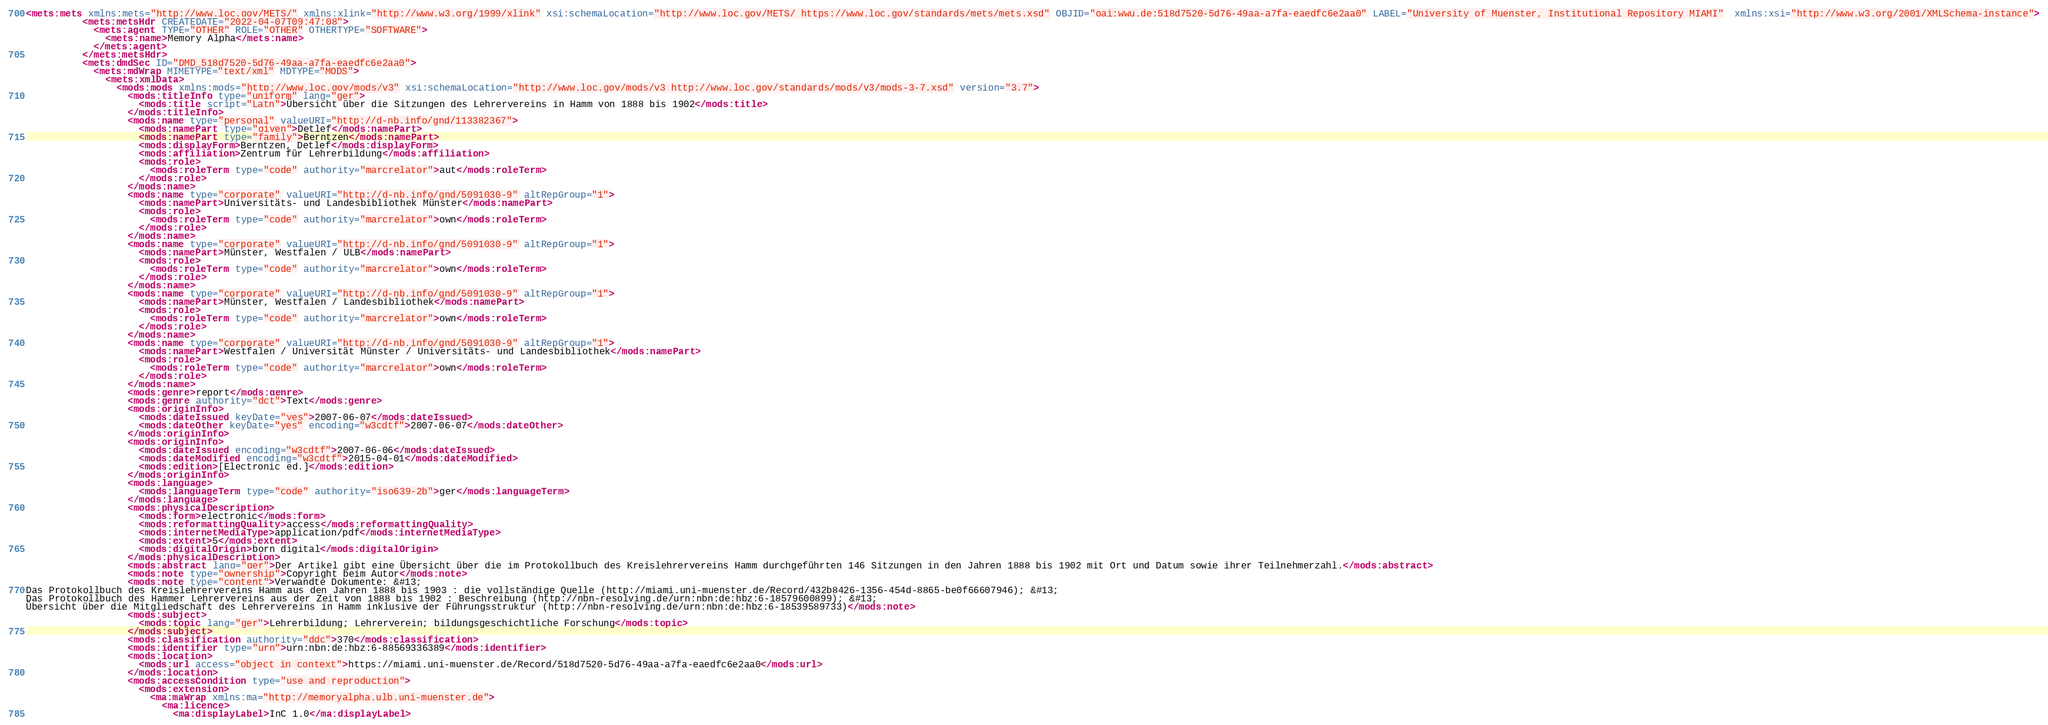<code> <loc_0><loc_0><loc_500><loc_500><_XML_><mets:mets xmlns:mets="http://www.loc.gov/METS/" xmlns:xlink="http://www.w3.org/1999/xlink" xsi:schemaLocation="http://www.loc.gov/METS/ https://www.loc.gov/standards/mets/mets.xsd" OBJID="oai:wwu.de:518d7520-5d76-49aa-a7fa-eaedfc6e2aa0" LABEL="University of Muenster, Institutional Repository MIAMI"  xmlns:xsi="http://www.w3.org/2001/XMLSchema-instance">
          <mets:metsHdr CREATEDATE="2022-04-07T09:47:08">
            <mets:agent TYPE="OTHER" ROLE="OTHER" OTHERTYPE="SOFTWARE">
              <mets:name>Memory Alpha</mets:name>
            </mets:agent>
          </mets:metsHdr>
          <mets:dmdSec ID="DMD_518d7520-5d76-49aa-a7fa-eaedfc6e2aa0">
            <mets:mdWrap MIMETYPE="text/xml" MDTYPE="MODS">
              <mets:xmlData>
                <mods:mods xmlns:mods="http://www.loc.gov/mods/v3" xsi:schemaLocation="http://www.loc.gov/mods/v3 http://www.loc.gov/standards/mods/v3/mods-3-7.xsd" version="3.7">
                  <mods:titleInfo type="uniform" lang="ger">
                    <mods:title script="Latn">Übersicht über die Sitzungen des Lehrervereins in Hamm von 1888 bis 1902</mods:title>
                  </mods:titleInfo>
                  <mods:name type="personal" valueURI="http://d-nb.info/gnd/113382367">
                    <mods:namePart type="given">Detlef</mods:namePart>
                    <mods:namePart type="family">Berntzen</mods:namePart>
                    <mods:displayForm>Berntzen, Detlef</mods:displayForm>
                    <mods:affiliation>Zentrum für Lehrerbildung</mods:affiliation>
                    <mods:role>
                      <mods:roleTerm type="code" authority="marcrelator">aut</mods:roleTerm>
                    </mods:role>
                  </mods:name>
                  <mods:name type="corporate" valueURI="http://d-nb.info/gnd/5091030-9" altRepGroup="1">
                    <mods:namePart>Universitäts- und Landesbibliothek Münster</mods:namePart>
                    <mods:role>
                      <mods:roleTerm type="code" authority="marcrelator">own</mods:roleTerm>
                    </mods:role>
                  </mods:name>
                  <mods:name type="corporate" valueURI="http://d-nb.info/gnd/5091030-9" altRepGroup="1">
                    <mods:namePart>Münster, Westfalen / ULB</mods:namePart>
                    <mods:role>
                      <mods:roleTerm type="code" authority="marcrelator">own</mods:roleTerm>
                    </mods:role>
                  </mods:name>
                  <mods:name type="corporate" valueURI="http://d-nb.info/gnd/5091030-9" altRepGroup="1">
                    <mods:namePart>Münster, Westfalen / Landesbibliothek</mods:namePart>
                    <mods:role>
                      <mods:roleTerm type="code" authority="marcrelator">own</mods:roleTerm>
                    </mods:role>
                  </mods:name>
                  <mods:name type="corporate" valueURI="http://d-nb.info/gnd/5091030-9" altRepGroup="1">
                    <mods:namePart>Westfalen / Universität Münster / Universitäts- und Landesbibliothek</mods:namePart>
                    <mods:role>
                      <mods:roleTerm type="code" authority="marcrelator">own</mods:roleTerm>
                    </mods:role>
                  </mods:name>
                  <mods:genre>report</mods:genre>
                  <mods:genre authority="dct">Text</mods:genre>
                  <mods:originInfo>
                    <mods:dateIssued keyDate="yes">2007-06-07</mods:dateIssued>
                    <mods:dateOther keyDate="yes" encoding="w3cdtf">2007-06-07</mods:dateOther>
                  </mods:originInfo>
                  <mods:originInfo>
                    <mods:dateIssued encoding="w3cdtf">2007-06-06</mods:dateIssued>
                    <mods:dateModified encoding="w3cdtf">2015-04-01</mods:dateModified>
                    <mods:edition>[Electronic ed.]</mods:edition>
                  </mods:originInfo>
                  <mods:language>
                    <mods:languageTerm type="code" authority="iso639-2b">ger</mods:languageTerm>
                  </mods:language>
                  <mods:physicalDescription>
                    <mods:form>electronic</mods:form>
                    <mods:reformattingQuality>access</mods:reformattingQuality>
                    <mods:internetMediaType>application/pdf</mods:internetMediaType>
                    <mods:extent>5</mods:extent>
                    <mods:digitalOrigin>born digital</mods:digitalOrigin>
                  </mods:physicalDescription>
                  <mods:abstract lang="ger">Der Artikel gibt eine Übersicht über die im Protokollbuch des Kreislehrervereins Hamm durchgeführten 146 Sitzungen in den Jahren 1888 bis 1902 mit Ort und Datum sowie ihrer Teilnehmerzahl.</mods:abstract>
                  <mods:note type="ownership">Copyright beim Autor</mods:note>
                  <mods:note type="content">Verwandte Dokumente: &#13;
Das Protokollbuch des Kreislehrervereins Hamm aus den Jahren 1888 bis 1903 : die vollständige Quelle (http://miami.uni-muenster.de/Record/432b8426-1356-454d-8865-be0f66607946); &#13;
Das Protokollbuch des Hammer Lehrervereins aus der Zeit von 1888 bis 1902 : Beschreibung (http://nbn-resolving.de/urn:nbn:de:hbz:6-18579600899); &#13;
Übersicht über die Mitgliedschaft des Lehrervereins in Hamm inklusive der Führungsstruktur (http://nbn-resolving.de/urn:nbn:de:hbz:6-18539589733)</mods:note>
                  <mods:subject>
                    <mods:topic lang="ger">Lehrerbildung; Lehrerverein; bildungsgeschichtliche Forschung</mods:topic>
                  </mods:subject>
                  <mods:classification authority="ddc">370</mods:classification>
                  <mods:identifier type="urn">urn:nbn:de:hbz:6-88569336389</mods:identifier>
                  <mods:location>
                    <mods:url access="object in context">https://miami.uni-muenster.de/Record/518d7520-5d76-49aa-a7fa-eaedfc6e2aa0</mods:url>
                  </mods:location>
                  <mods:accessCondition type="use and reproduction">
                    <mods:extension>
                      <ma:maWrap xmlns:ma="http://memoryalpha.ulb.uni-muenster.de">
                        <ma:licence>
                          <ma:displayLabel>InC 1.0</ma:displayLabel></code> 